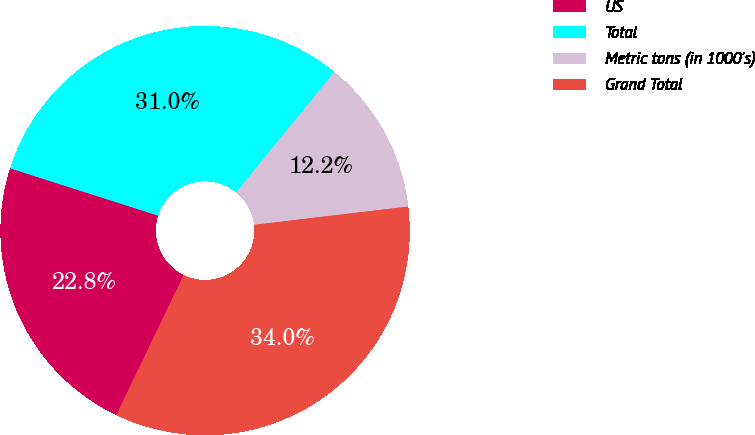<chart> <loc_0><loc_0><loc_500><loc_500><pie_chart><fcel>US<fcel>Total<fcel>Metric tons (in 1000's)<fcel>Grand Total<nl><fcel>22.79%<fcel>30.95%<fcel>12.24%<fcel>34.01%<nl></chart> 